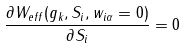Convert formula to latex. <formula><loc_0><loc_0><loc_500><loc_500>\frac { \partial W _ { e f f } ( g _ { k } , S _ { i } , w _ { i \alpha } = 0 ) } { \partial S _ { i } } = 0</formula> 